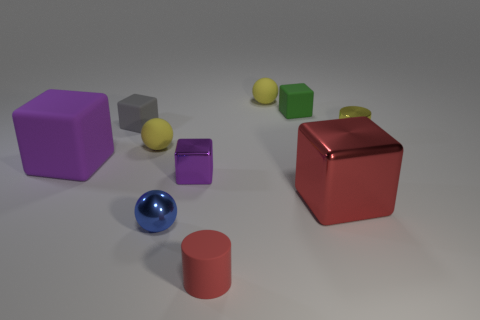Subtract all large purple rubber cubes. How many cubes are left? 4 Subtract all green blocks. How many blocks are left? 4 Subtract all yellow cubes. Subtract all green cylinders. How many cubes are left? 5 Subtract all cylinders. How many objects are left? 8 Subtract all tiny gray cubes. Subtract all green matte objects. How many objects are left? 8 Add 2 yellow cylinders. How many yellow cylinders are left? 3 Add 7 cyan shiny blocks. How many cyan shiny blocks exist? 7 Subtract 1 green cubes. How many objects are left? 9 